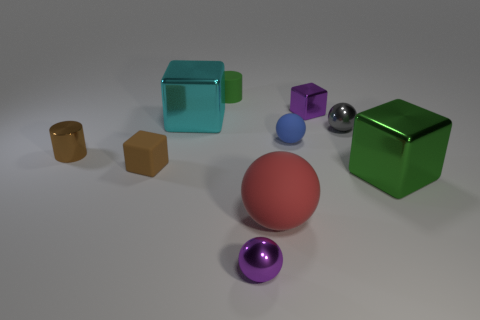Subtract all spheres. How many objects are left? 6 Add 3 cyan objects. How many cyan objects exist? 4 Subtract 1 brown blocks. How many objects are left? 9 Subtract all large objects. Subtract all cyan things. How many objects are left? 6 Add 9 tiny brown rubber blocks. How many tiny brown rubber blocks are left? 10 